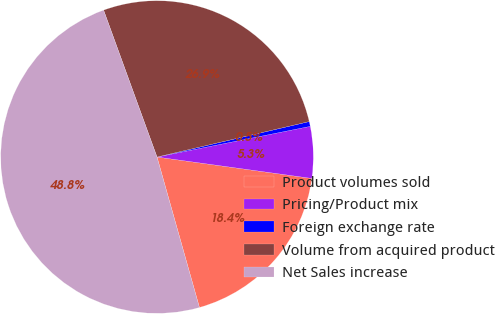Convert chart to OTSL. <chart><loc_0><loc_0><loc_500><loc_500><pie_chart><fcel>Product volumes sold<fcel>Pricing/Product mix<fcel>Foreign exchange rate<fcel>Volume from acquired product<fcel>Net Sales increase<nl><fcel>18.44%<fcel>5.33%<fcel>0.5%<fcel>26.91%<fcel>48.83%<nl></chart> 